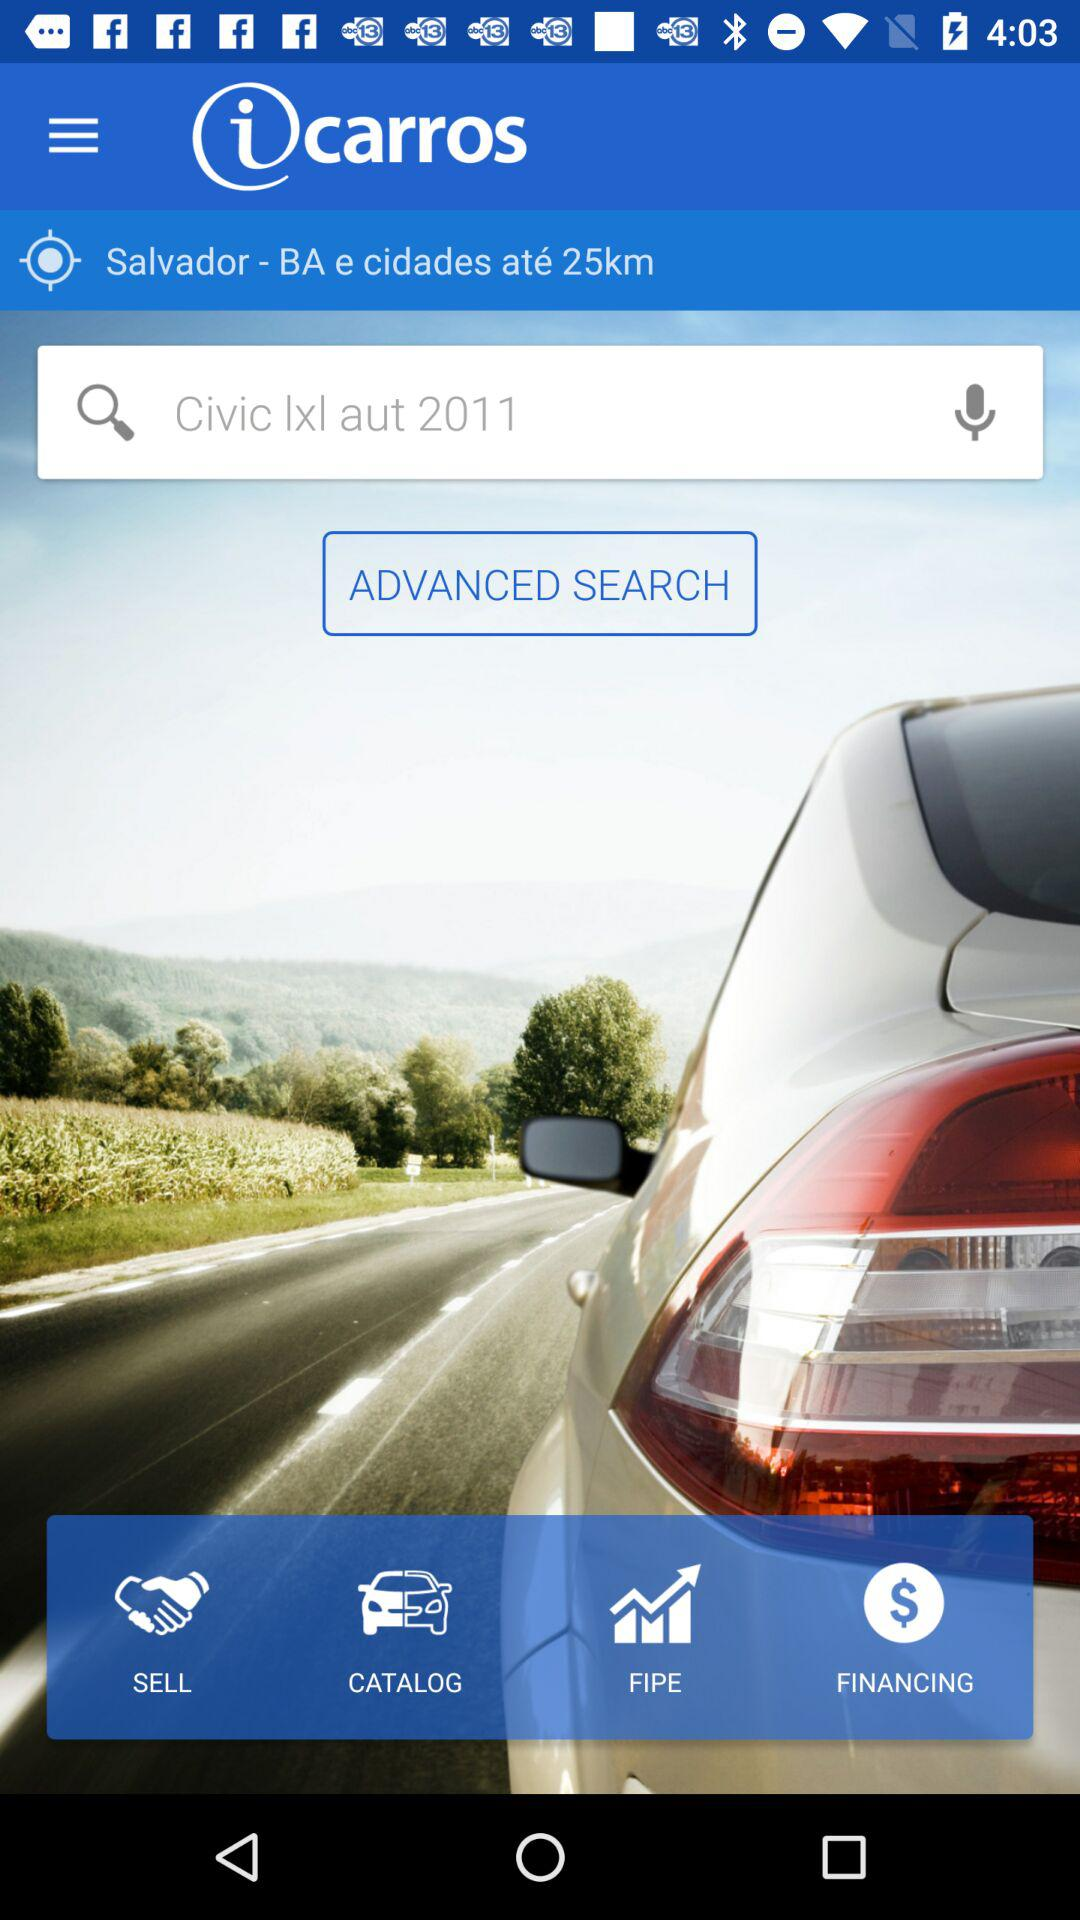What is the name of the application? The name of the application is "iCarros: Carros Usados e Novos". 